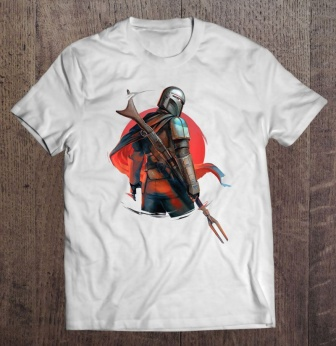What historical period do you think the knight's armor is inspired by? The knight's armor design suggests inspiration from late medieval Europe, specifically around the 15th century. Notably, the layered plates and the intricate detailing on the armor speak to advancements in metallurgy and craftsmanship typical of the late Middle Ages, aimed at offering both flexibility and protection in battle. 